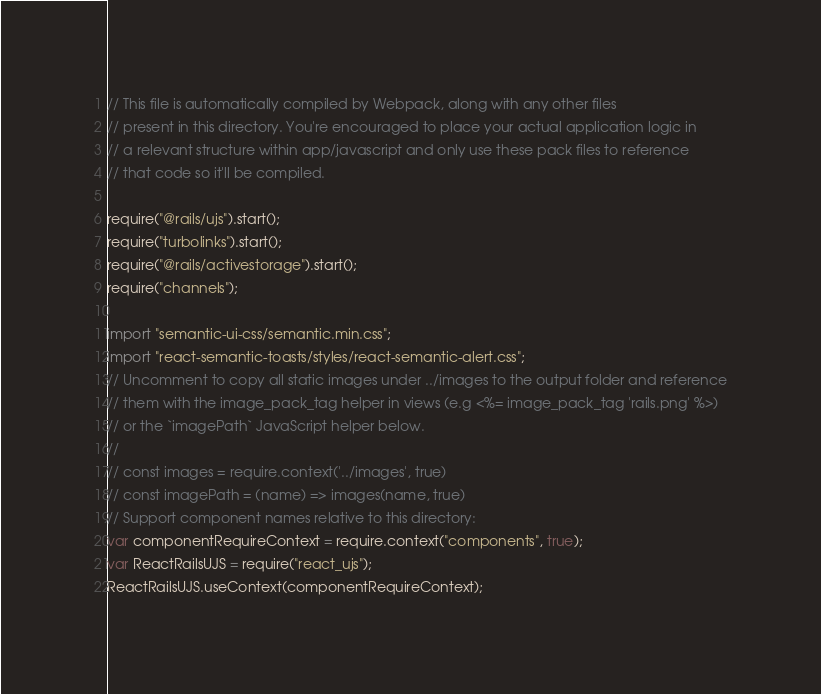<code> <loc_0><loc_0><loc_500><loc_500><_JavaScript_>// This file is automatically compiled by Webpack, along with any other files
// present in this directory. You're encouraged to place your actual application logic in
// a relevant structure within app/javascript and only use these pack files to reference
// that code so it'll be compiled.

require("@rails/ujs").start();
require("turbolinks").start();
require("@rails/activestorage").start();
require("channels");

import "semantic-ui-css/semantic.min.css";
import "react-semantic-toasts/styles/react-semantic-alert.css";
// Uncomment to copy all static images under ../images to the output folder and reference
// them with the image_pack_tag helper in views (e.g <%= image_pack_tag 'rails.png' %>)
// or the `imagePath` JavaScript helper below.
//
// const images = require.context('../images', true)
// const imagePath = (name) => images(name, true)
// Support component names relative to this directory:
var componentRequireContext = require.context("components", true);
var ReactRailsUJS = require("react_ujs");
ReactRailsUJS.useContext(componentRequireContext);
</code> 